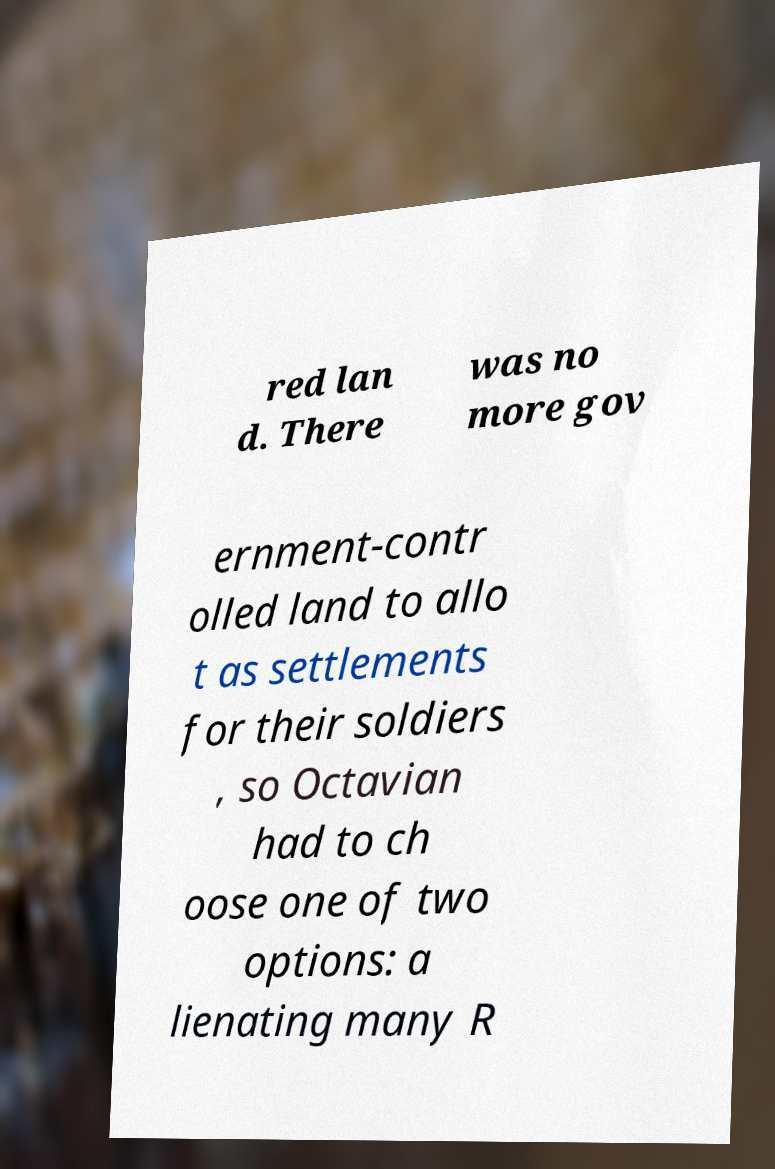Could you assist in decoding the text presented in this image and type it out clearly? red lan d. There was no more gov ernment-contr olled land to allo t as settlements for their soldiers , so Octavian had to ch oose one of two options: a lienating many R 